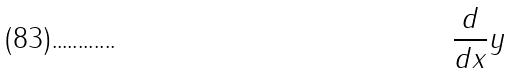<formula> <loc_0><loc_0><loc_500><loc_500>\frac { d } { d x } y</formula> 